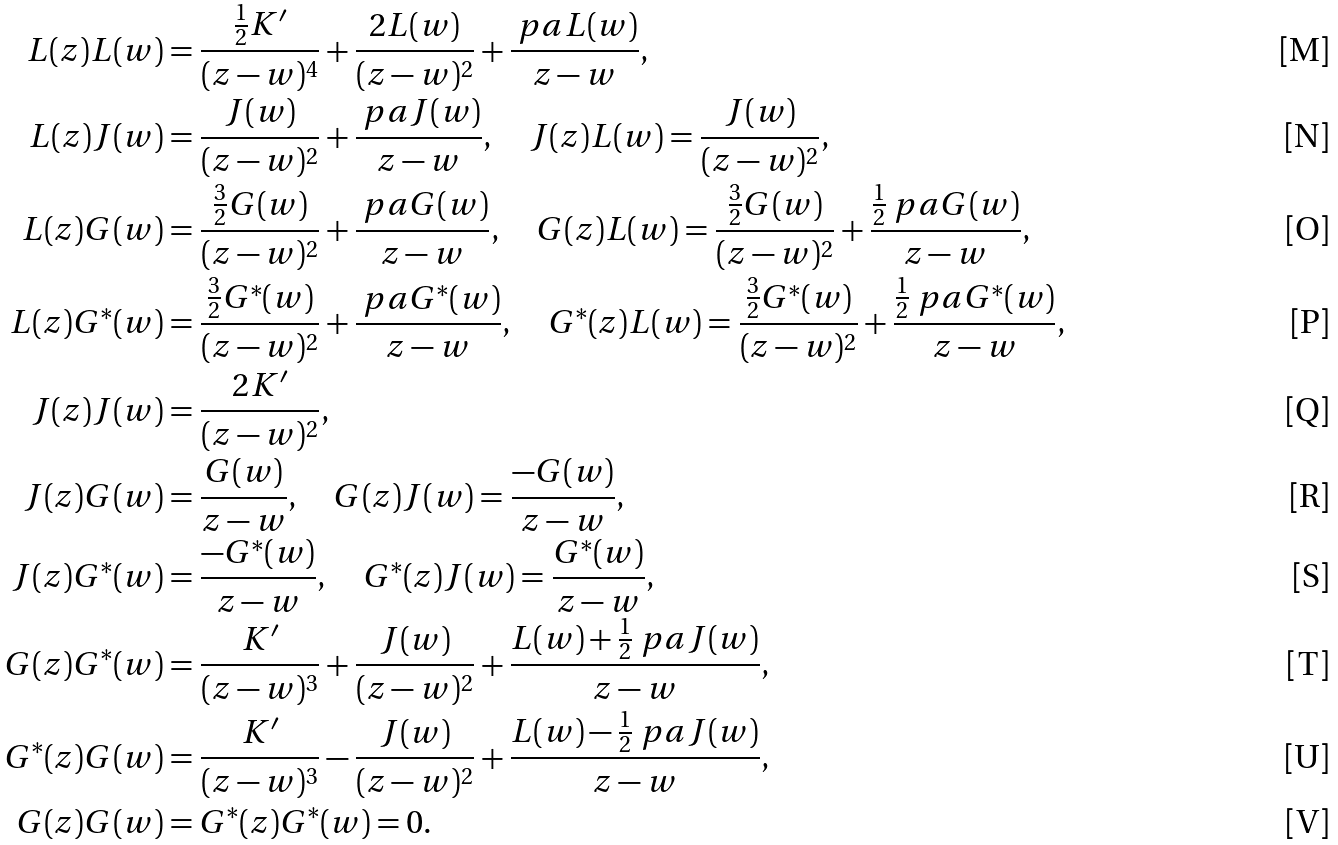Convert formula to latex. <formula><loc_0><loc_0><loc_500><loc_500>L ( z ) L ( w ) & = \frac { \frac { 1 } { 2 } K ^ { \prime } } { ( z - w ) ^ { 4 } } + \frac { 2 L ( w ) } { ( z - w ) ^ { 2 } } + \frac { \ p a L ( w ) } { z - w } , \\ L ( z ) J ( w ) & = \frac { J ( w ) } { ( z - w ) ^ { 2 } } + \frac { \ p a J ( w ) } { z - w } , \quad J ( z ) L ( w ) = \frac { J ( w ) } { ( z - w ) ^ { 2 } } , \\ L ( z ) G ( w ) & = \frac { \frac { 3 } { 2 } G ( w ) } { ( z - w ) ^ { 2 } } + \frac { \ p a G ( w ) } { z - w } , \quad G ( z ) L ( w ) = \frac { \frac { 3 } { 2 } G ( w ) } { ( z - w ) ^ { 2 } } + \frac { \frac { 1 } { 2 } \ p a G ( w ) } { z - w } , \\ L ( z ) G ^ { \ast } ( w ) & = \frac { \frac { 3 } { 2 } G ^ { \ast } ( w ) } { ( z - w ) ^ { 2 } } + \frac { \ p a G ^ { \ast } ( w ) } { z - w } , \quad G ^ { \ast } ( z ) L ( w ) = \frac { \frac { 3 } { 2 } G ^ { \ast } ( w ) } { ( z - w ) ^ { 2 } } + \frac { \frac { 1 } { 2 } \ p a G ^ { \ast } ( w ) } { z - w } , \\ J ( z ) J ( w ) & = \frac { 2 K ^ { \prime } } { ( z - w ) ^ { 2 } } , \\ J ( z ) G ( w ) & = \frac { G ( w ) } { z - w } , \quad G ( z ) J ( w ) = \frac { - G ( w ) } { z - w } , \\ J ( z ) G ^ { \ast } ( w ) & = \frac { - G ^ { \ast } ( w ) } { z - w } , \quad G ^ { \ast } ( z ) J ( w ) = \frac { G ^ { \ast } ( w ) } { z - w } , \\ G ( z ) G ^ { \ast } ( w ) & = \frac { K ^ { \prime } } { ( z - w ) ^ { 3 } } + \frac { J ( w ) } { ( z - w ) ^ { 2 } } + \frac { L ( w ) + \frac { 1 } { 2 } \ p a J ( w ) } { z - w } , \\ G ^ { \ast } ( z ) G ( w ) & = \frac { K ^ { \prime } } { ( z - w ) ^ { 3 } } - \frac { J ( w ) } { ( z - w ) ^ { 2 } } + \frac { L ( w ) - \frac { 1 } { 2 } \ p a J ( w ) } { z - w } , \\ G ( z ) G ( w ) & = G ^ { \ast } ( z ) G ^ { \ast } ( w ) = 0 .</formula> 